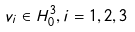<formula> <loc_0><loc_0><loc_500><loc_500>v _ { i } \in H _ { 0 } ^ { 3 } , i = 1 , 2 , 3</formula> 